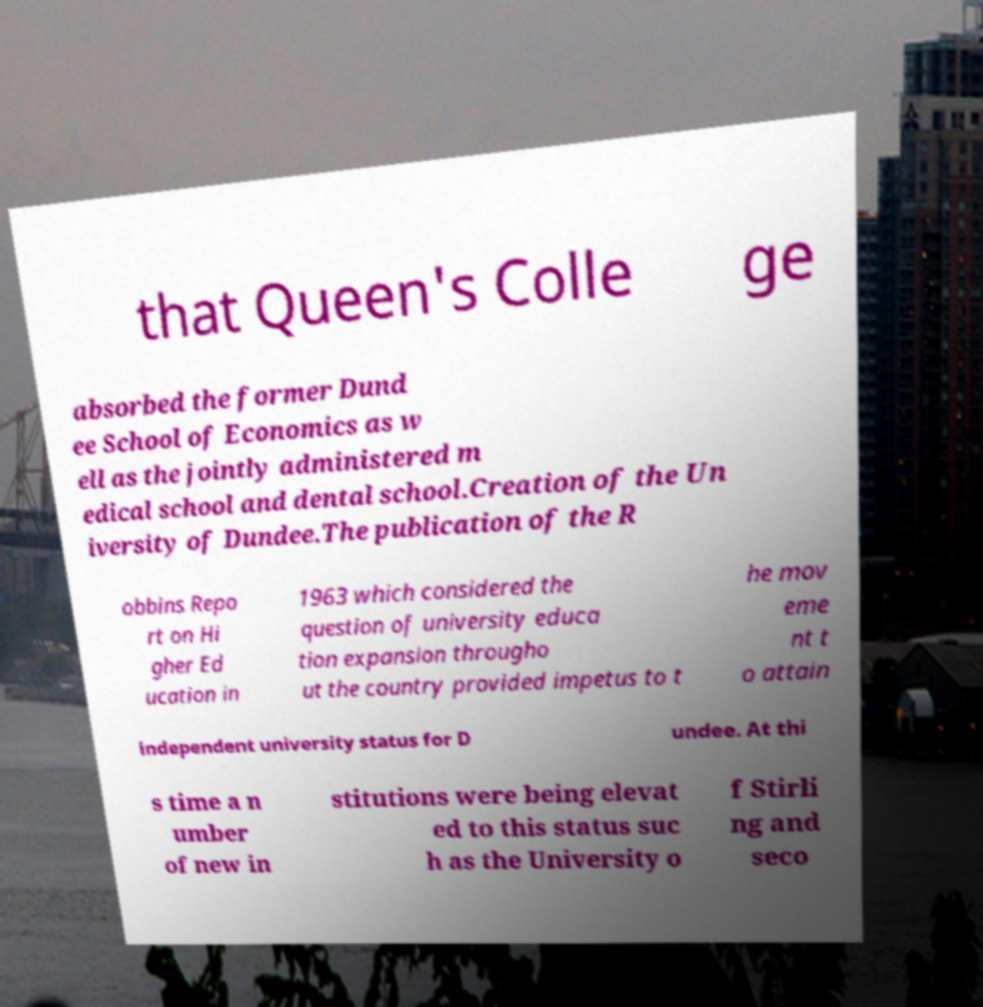Please read and relay the text visible in this image. What does it say? that Queen's Colle ge absorbed the former Dund ee School of Economics as w ell as the jointly administered m edical school and dental school.Creation of the Un iversity of Dundee.The publication of the R obbins Repo rt on Hi gher Ed ucation in 1963 which considered the question of university educa tion expansion througho ut the country provided impetus to t he mov eme nt t o attain independent university status for D undee. At thi s time a n umber of new in stitutions were being elevat ed to this status suc h as the University o f Stirli ng and seco 